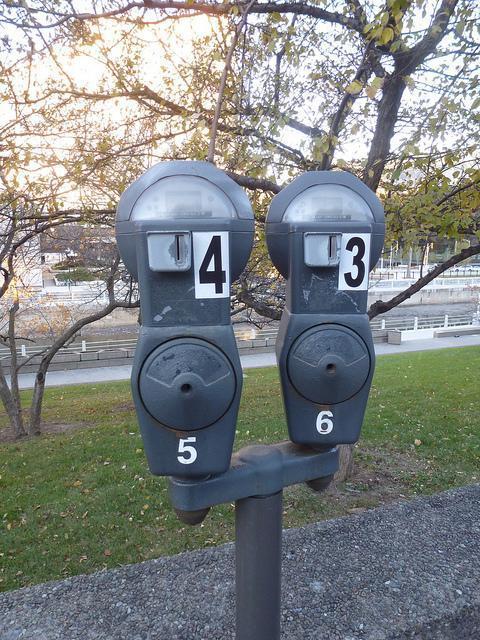How many parking spots are along this curb?
Give a very brief answer. 2. How many parking meters are visible?
Give a very brief answer. 2. 